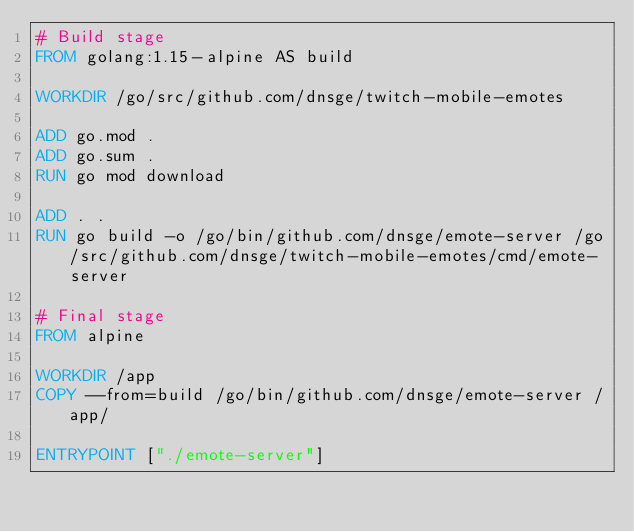Convert code to text. <code><loc_0><loc_0><loc_500><loc_500><_Dockerfile_># Build stage
FROM golang:1.15-alpine AS build

WORKDIR /go/src/github.com/dnsge/twitch-mobile-emotes

ADD go.mod .
ADD go.sum .
RUN go mod download

ADD . .
RUN go build -o /go/bin/github.com/dnsge/emote-server /go/src/github.com/dnsge/twitch-mobile-emotes/cmd/emote-server

# Final stage
FROM alpine

WORKDIR /app
COPY --from=build /go/bin/github.com/dnsge/emote-server /app/

ENTRYPOINT ["./emote-server"]
</code> 